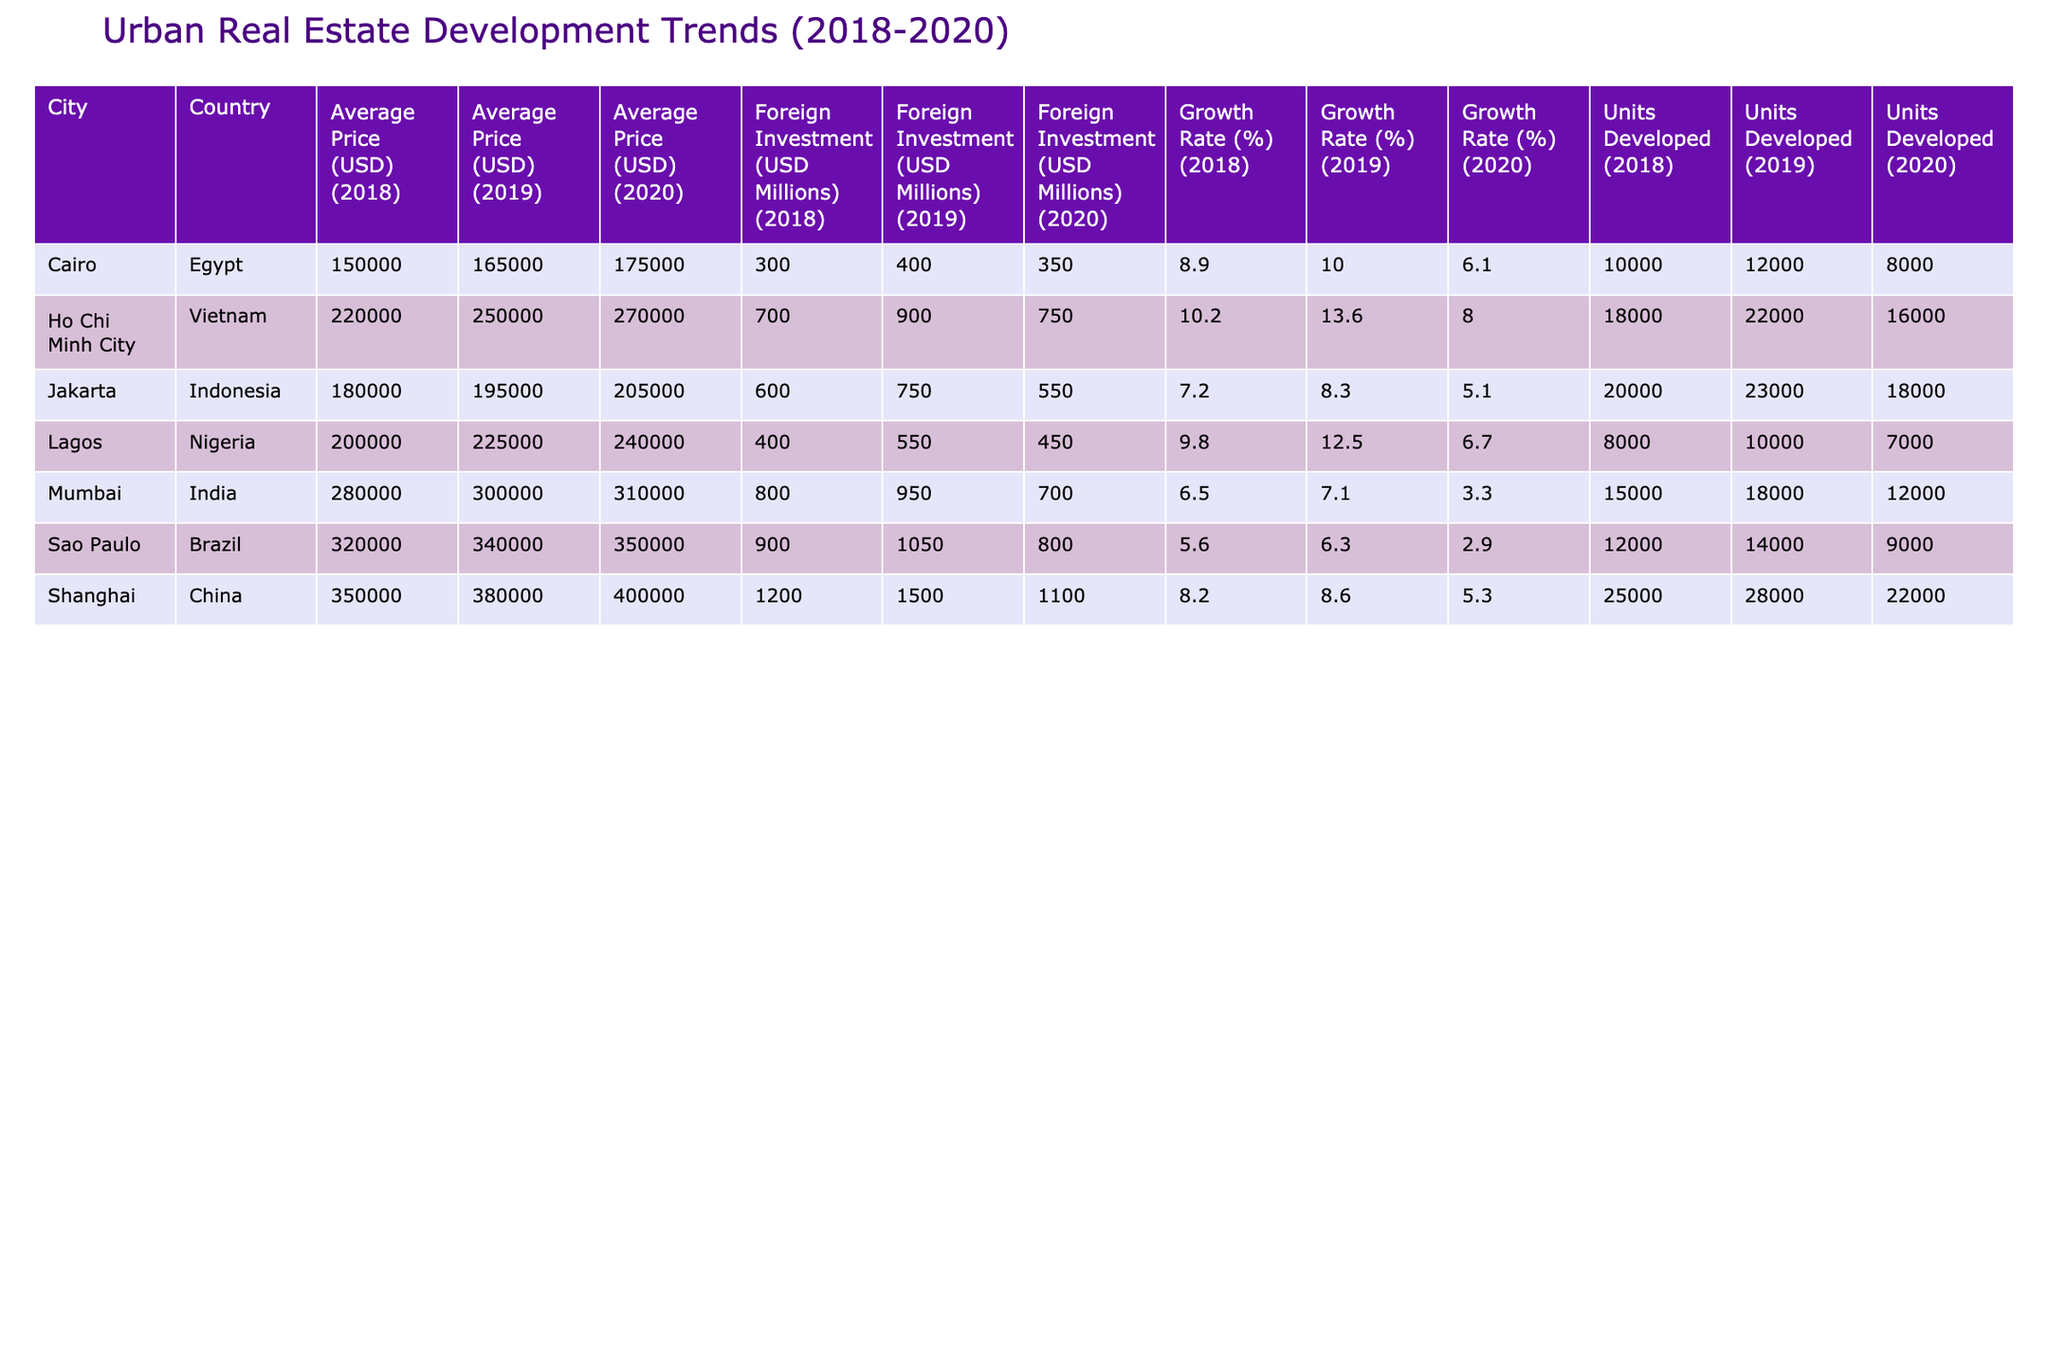What was the average price of residential properties in Shanghai in 2019? Looking at the table, we can find the row for Shanghai under the Residential property type for the year 2019, which shows the average price as 380,000 USD.
Answer: 380,000 USD Which city had the highest average price for commercial properties in 2020? The table indicates that Sao Paulo has an average price of 350,000 USD for commercial properties in 2020, while Mumbai's average price is 310,000 USD. Thus, Sao Paulo had the highest.
Answer: Sao Paulo What was the growth rate of mixed-use properties in Lagos from 2019 to 2020? The growth rate for mixed-use properties in Lagos was 12.5% in 2019 and dropped to 6.7% in 2020. To find the change, we subtract: 6.7% - 12.5% = -5.8%. Hence, there was a decline in growth rate.
Answer: -5.8% Did Ho Chi Minh City experience an increase in property value from 2018 to 2020? In 2018, the average price was 220,000 USD, which increased to 270,000 USD in 2020. Taking the difference: 270,000 - 220,000 = 50,000 USD, confirming an increase.
Answer: Yes What was the sum of units developed for residential properties in Shanghai from 2018 to 2020? Adding the number of units developed in Shanghai for residential properties gives us 25,000 + 28,000 + 22,000 = 75,000 units developed in total for that period.
Answer: 75,000 units Which city saw the largest foreign investment in 2019? Checking the foreign investment for each city in 2019, Shanghai has 1,500 million USD, and Ho Chi Minh City has 900 million USD. The highest is in Shanghai with 1,500 million USD.
Answer: Shanghai What was the average growth rate of residential properties across all cities in 2020? To calculate the average growth rate for residential properties in 2020, we take the growth rates: Shanghai (5.3%), Jakarta (5.1%), and Cairo (6.1%), then calculate the mean: (5.3 + 5.1 + 6.1) / 3 = 5.5%.
Answer: 5.5% For which city was the growth rate for mixed-use properties the lowest in 2020? The table shows that Lagos had a growth rate of 6.7% while Ho Chi Minh City had 8.0% in 2020. Hence, Lagos had the lowest growth rate for mixed-use properties.
Answer: Lagos Did Cairo's residential properties witness a consistent increase in average price from 2018 to 2020? The average prices were 150,000 USD in 2018, increased to 165,000 USD in 2019, but then further increased to 175,000 USD in 2020. Thus, the prices increased consistently each year.
Answer: Yes 